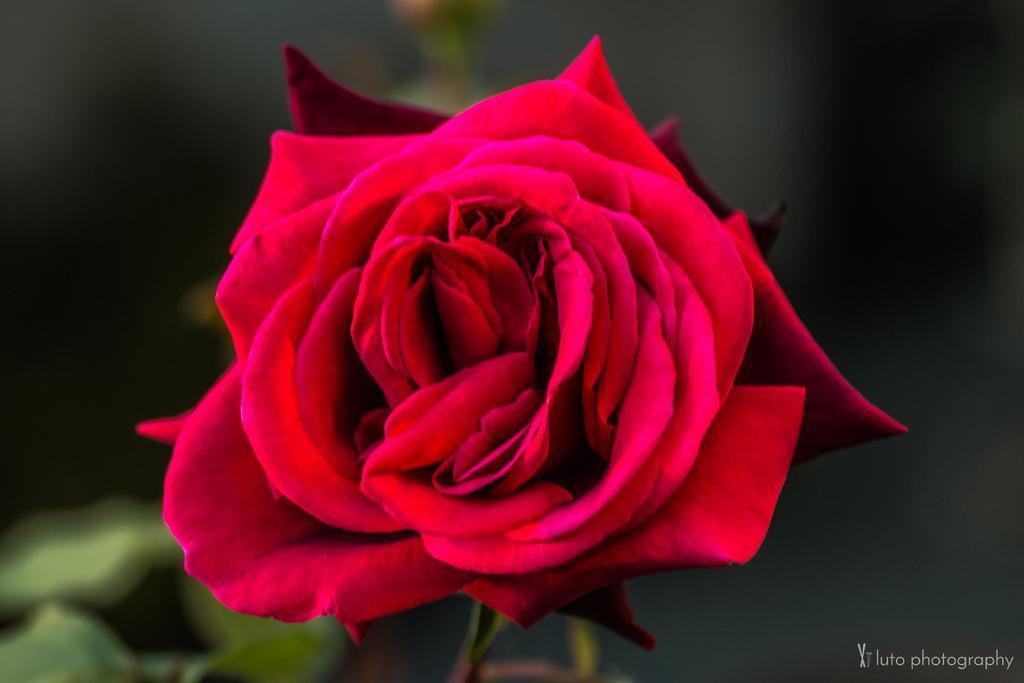Please provide a concise description of this image. In the picture I can see a red color flower. The background of the image is blurred. On the bottom right corner of the image I can see a watermark. 